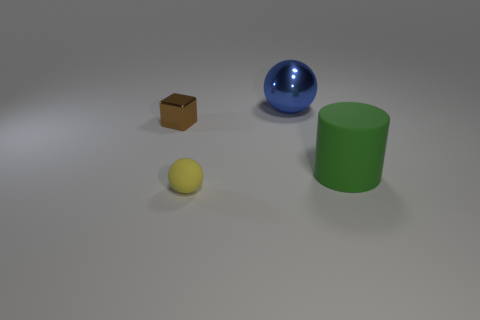Subtract all brown balls. Subtract all green cylinders. How many balls are left? 2 Subtract all yellow spheres. How many brown cylinders are left? 0 Add 2 objects. How many tiny grays exist? 0 Subtract all tiny rubber objects. Subtract all yellow balls. How many objects are left? 2 Add 1 blue objects. How many blue objects are left? 2 Add 3 large gray matte cubes. How many large gray matte cubes exist? 3 Add 1 brown blocks. How many objects exist? 5 Subtract all blue spheres. How many spheres are left? 1 Subtract 1 brown cubes. How many objects are left? 3 Subtract all blocks. How many objects are left? 3 